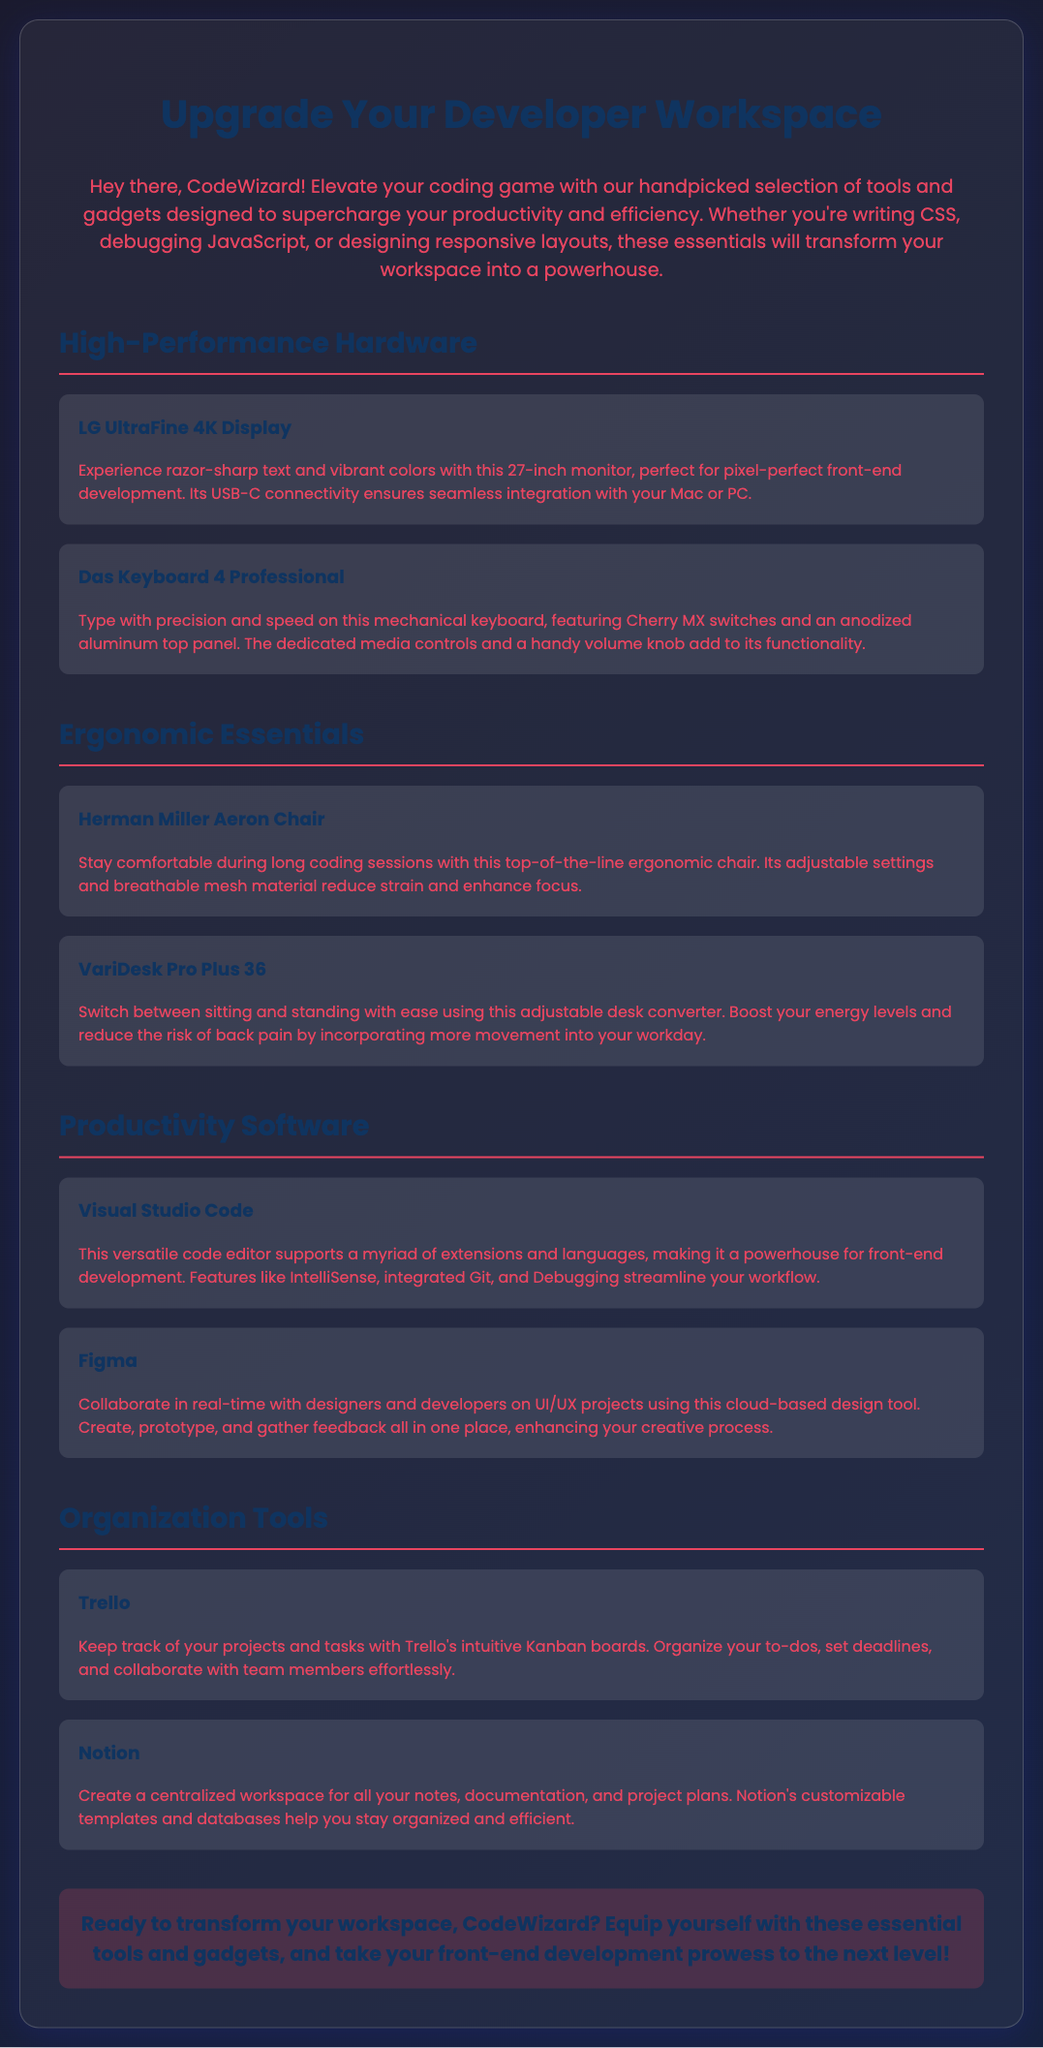What is the title of the document? The title is the main heading that appears at the top of the document, which indicates what the advertisement is about.
Answer: Upgrade Your Developer Workspace How many high-performance hardware tools are listed? The document includes a section for high-performance hardware tools, which contains two items.
Answer: 2 What brand is the ergonomic chair mentioned? The document specifies the brand of the ergonomic chair in the section on ergonomic essentials.
Answer: Herman Miller What is the main purpose of the tools listed in the advertisement? The overall aim of these tools and gadgets is mentioned in the introduction, pointing towards improving productivity and efficiency for developers.
Answer: Boost Productivity and Efficiency What is the tool used for task organization? This tool is clearly identified in the organization tools section of the document.
Answer: Trello Which productivity software is a code editor? The document clearly states the purpose of this software in the productivity software section.
Answer: Visual Studio Code What feature does the LG UltraFine 4K Display support? The description of the monitor in the advertisement mentions a specific type of connectivity.
Answer: USB-C connectivity How does the VariDesk Pro Plus 36 improve workday experience? The advantages of using this desk converter are listed in its description under ergonomic essentials.
Answer: Incorporating more movement 